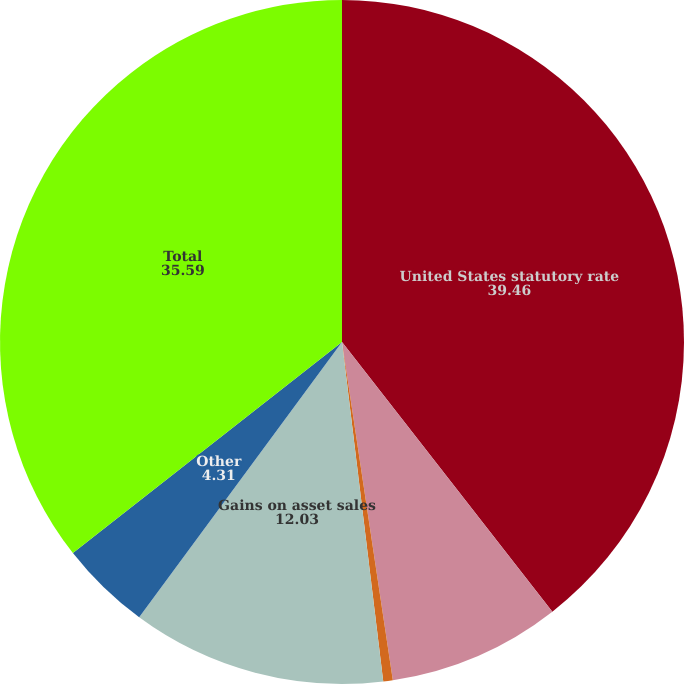Convert chart. <chart><loc_0><loc_0><loc_500><loc_500><pie_chart><fcel>United States statutory rate<fcel>Effect of foreign operations<fcel>State income taxes net of<fcel>Gains on asset sales<fcel>Other<fcel>Total<nl><fcel>39.46%<fcel>8.17%<fcel>0.45%<fcel>12.03%<fcel>4.31%<fcel>35.59%<nl></chart> 